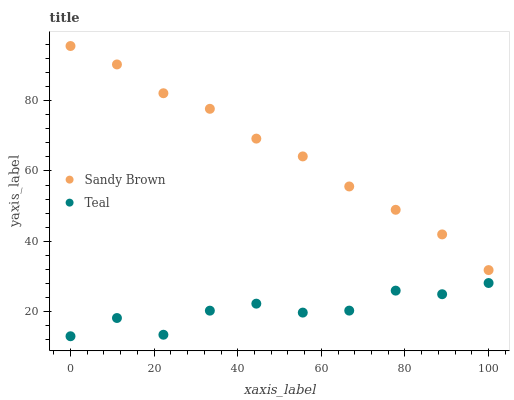Does Teal have the minimum area under the curve?
Answer yes or no. Yes. Does Sandy Brown have the maximum area under the curve?
Answer yes or no. Yes. Does Teal have the maximum area under the curve?
Answer yes or no. No. Is Sandy Brown the smoothest?
Answer yes or no. Yes. Is Teal the roughest?
Answer yes or no. Yes. Is Teal the smoothest?
Answer yes or no. No. Does Teal have the lowest value?
Answer yes or no. Yes. Does Sandy Brown have the highest value?
Answer yes or no. Yes. Does Teal have the highest value?
Answer yes or no. No. Is Teal less than Sandy Brown?
Answer yes or no. Yes. Is Sandy Brown greater than Teal?
Answer yes or no. Yes. Does Teal intersect Sandy Brown?
Answer yes or no. No. 